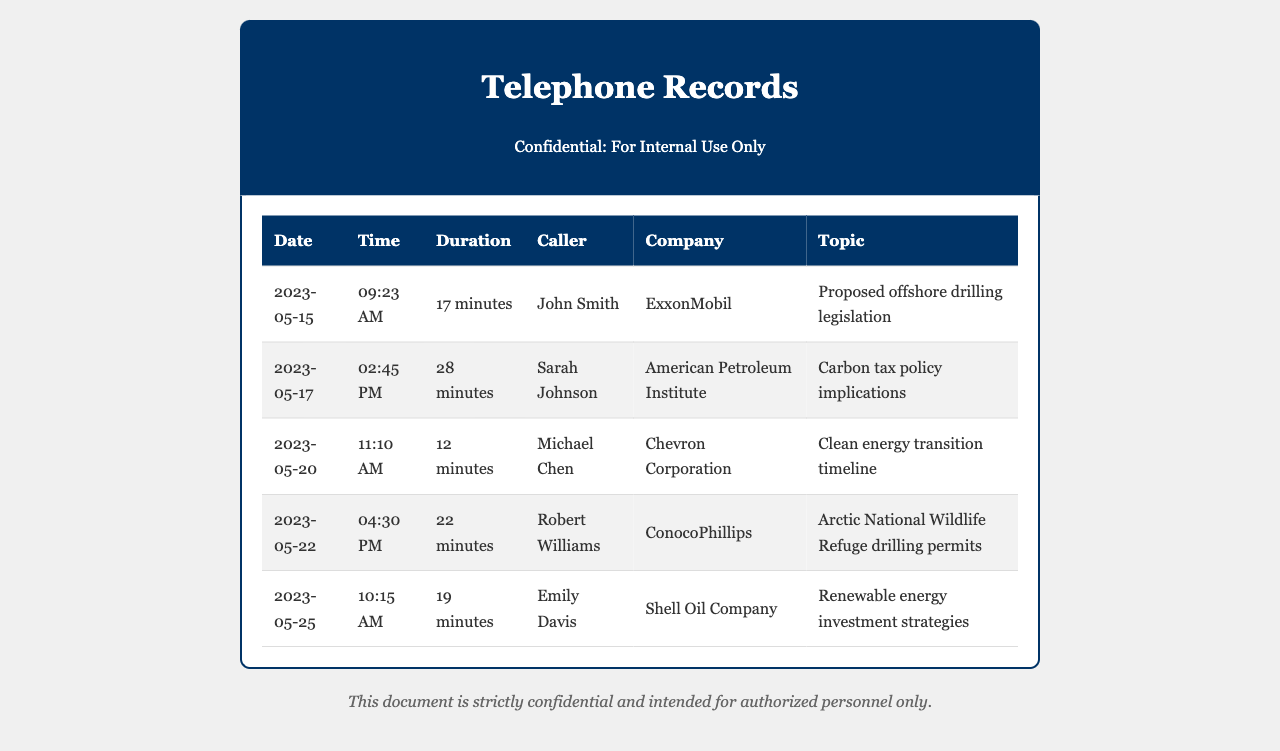What is the date of the conversation with John Smith? The date of the conversation with John Smith is listed in the telephone records.
Answer: 2023-05-15 What company is associated with the call about carbon tax policy implications? The company mentioned in connection with the call about carbon tax policy implications is noted in the records.
Answer: American Petroleum Institute What was the duration of the conversation with Michael Chen? The duration of the conversation is provided for each entry in the document.
Answer: 12 minutes Who called regarding the Arctic National Wildlife Refuge drilling permits? The caller inquiring about drilling permits is specified in the table.
Answer: Robert Williams Which date had the longest call duration? To find this, the call durations from all entries need to be compared.
Answer: 28 minutes How many conversations were with individuals from ExxonMobil or Chevron Corporation? This requires counting specific entries for ExxonMobil and Chevron Corporation in the document.
Answer: 2 What topic was discussed during the call on May 22, 2023? The topic is explicitly mentioned in the records for that date.
Answer: Arctic National Wildlife Refuge drilling permits What time was the call with Emily Davis? The time of the call is clearly outlined in the records.
Answer: 10:15 AM How many unique companies were involved in these conversations? This requires identifying the distinct companies listed in the document.
Answer: 5 